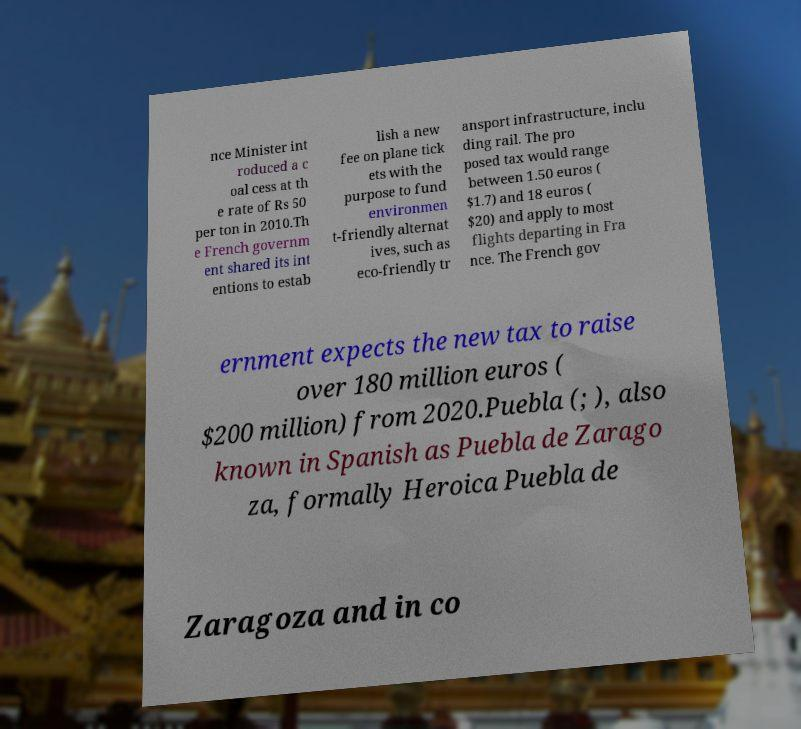Could you assist in decoding the text presented in this image and type it out clearly? nce Minister int roduced a c oal cess at th e rate of Rs 50 per ton in 2010.Th e French governm ent shared its int entions to estab lish a new fee on plane tick ets with the purpose to fund environmen t-friendly alternat ives, such as eco-friendly tr ansport infrastructure, inclu ding rail. The pro posed tax would range between 1.50 euros ( $1.7) and 18 euros ( $20) and apply to most flights departing in Fra nce. The French gov ernment expects the new tax to raise over 180 million euros ( $200 million) from 2020.Puebla (; ), also known in Spanish as Puebla de Zarago za, formally Heroica Puebla de Zaragoza and in co 